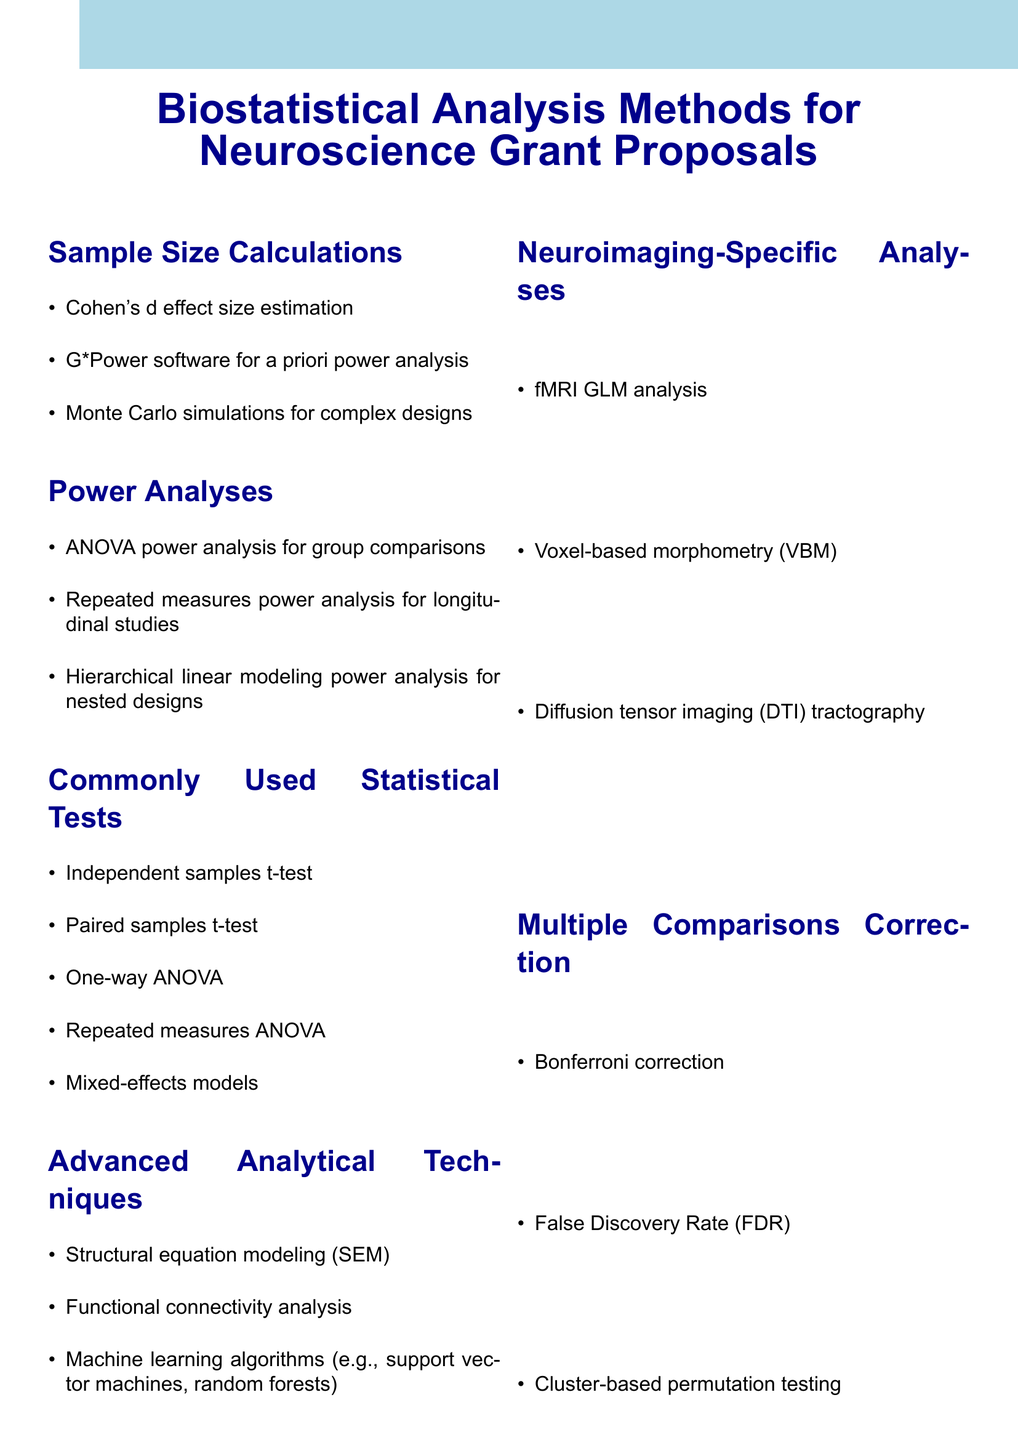What are the methods mentioned for sample size calculations? The document lists Cohen's d effect size estimation, G*Power software for a priori power analysis, and Monte Carlo simulations for complex designs under the sample size calculations section.
Answer: Cohen's d effect size estimation, G*Power software, Monte Carlo simulations Which statistical test is commonly used for group comparisons? The document states that the independent samples t-test is commonly used for group comparisons in the section on commonly used statistical tests.
Answer: Independent samples t-test What is one of the important considerations mentioned? The document outlines several important considerations, one of which is the justification of sample size based on previous literature.
Answer: Justification of sample size based on previous literature Name a recommended software for biostatistical analysis. The document recommends several software options for biostatistical analysis, including SPSS.
Answer: SPSS Which method is used for neuroimaging analysis? The document identifies fMRI GLM analysis as one of the methods specifically used for neuroimaging analyses under the neuroimaging-specific analyses section.
Answer: fMRI GLM analysis How many power analyses methods are listed? The document lists three methods under the power analyses section: ANOVA power analysis, repeated measures power analysis, and hierarchical linear modeling power analysis.
Answer: Three methods What correction method is used for multiple comparisons? The document mentions Bonferroni correction as one of the methods used for multiple comparisons correction in the corresponding section.
Answer: Bonferroni correction Which advanced analytical technique is mentioned? The document includes structural equation modeling (SEM) as one of the advanced analytical techniques under the advanced analytical techniques section.
Answer: Structural equation modeling (SEM) 